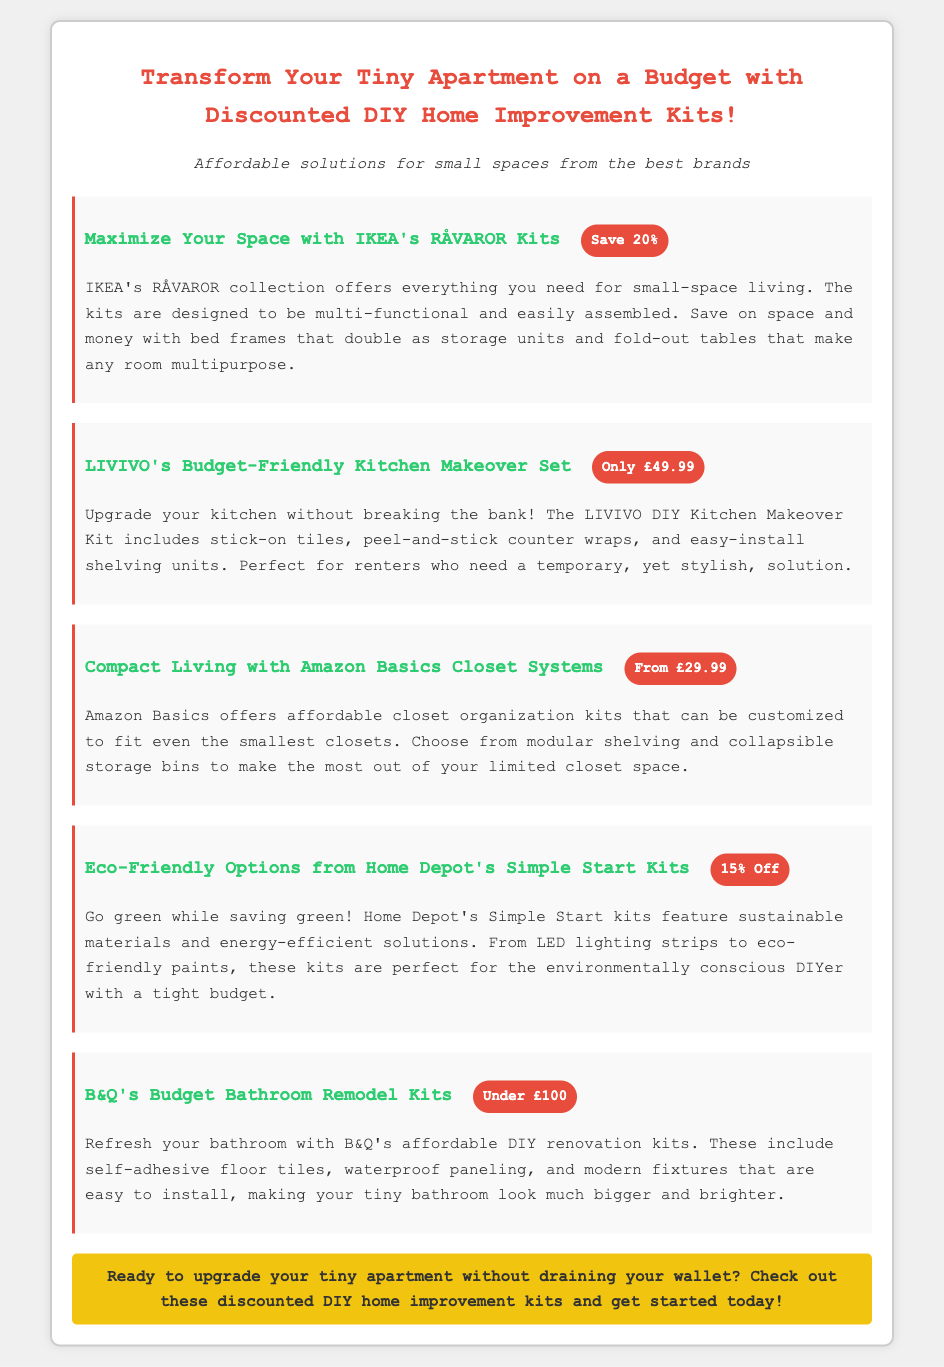What is the title of the advertisement? The title mentions transforming a tiny apartment on a budget with discounted DIY kits.
Answer: Transform Your Tiny Apartment on a Budget with Discounted DIY Home Improvement Kits! What brand offers the RÅVAROR Kits? The document specifies that these kits are from IKEA.
Answer: IKEA What is the price of LIVIVO's Kitchen Makeover Set? The advertisement states that this kit is priced at £49.99.
Answer: £49.99 How much can you save on IKEA's RÅVAROR Kits? The document indicates that you can save 20% on these kits.
Answer: Save 20% What is a feature of B&Q's Budget Bathroom Remodel Kits? The kits include self-adhesive floor tiles and waterproof paneling, making them easy to install.
Answer: Easy to install What is the minimum price for Amazon Basics Closet Systems? The advertisement mentions that the systems start from £29.99.
Answer: From £29.99 Which kit features sustainable materials? The document highlights Home Depot's Simple Start Kits as eco-friendly options.
Answer: Simple Start Kits What is the overall theme of the advertisement? The advertisement focuses on affordable DIY home improvement solutions for small spaces.
Answer: Affordable DIY home improvement solutions for small spaces Which product is highlighted for renters? The LIVIVO DIY Kitchen Makeover Kit is mentioned as perfect for renters needing temporary solutions.
Answer: LIVIVO DIY Kitchen Makeover Kit 